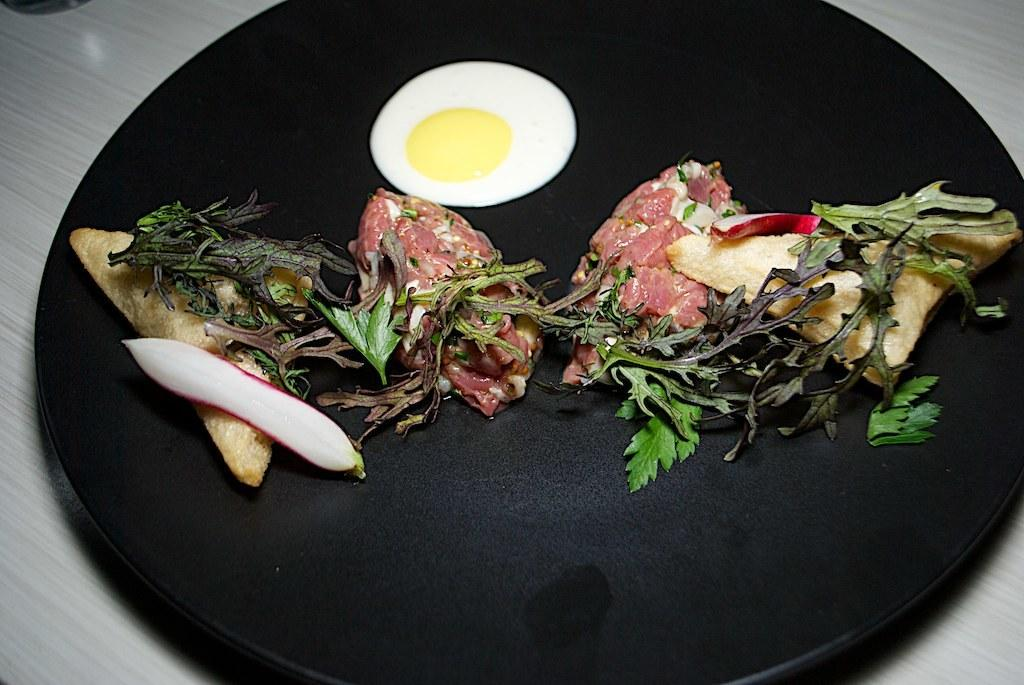What is the color of the main object in the image? There is a black object in the image. What is on the black object? There is food on the black object. Can you describe the colors of the food? The food has various colors, including white, yellow, green, red, and cream. What is the color of the surface the black object is on? The black object is on a white surface. How many crows are sitting on the black object in the image? There are no crows present in the image. What type of seat is on the black object in the image? There is no seat on the black object in the image; it is a food item. 